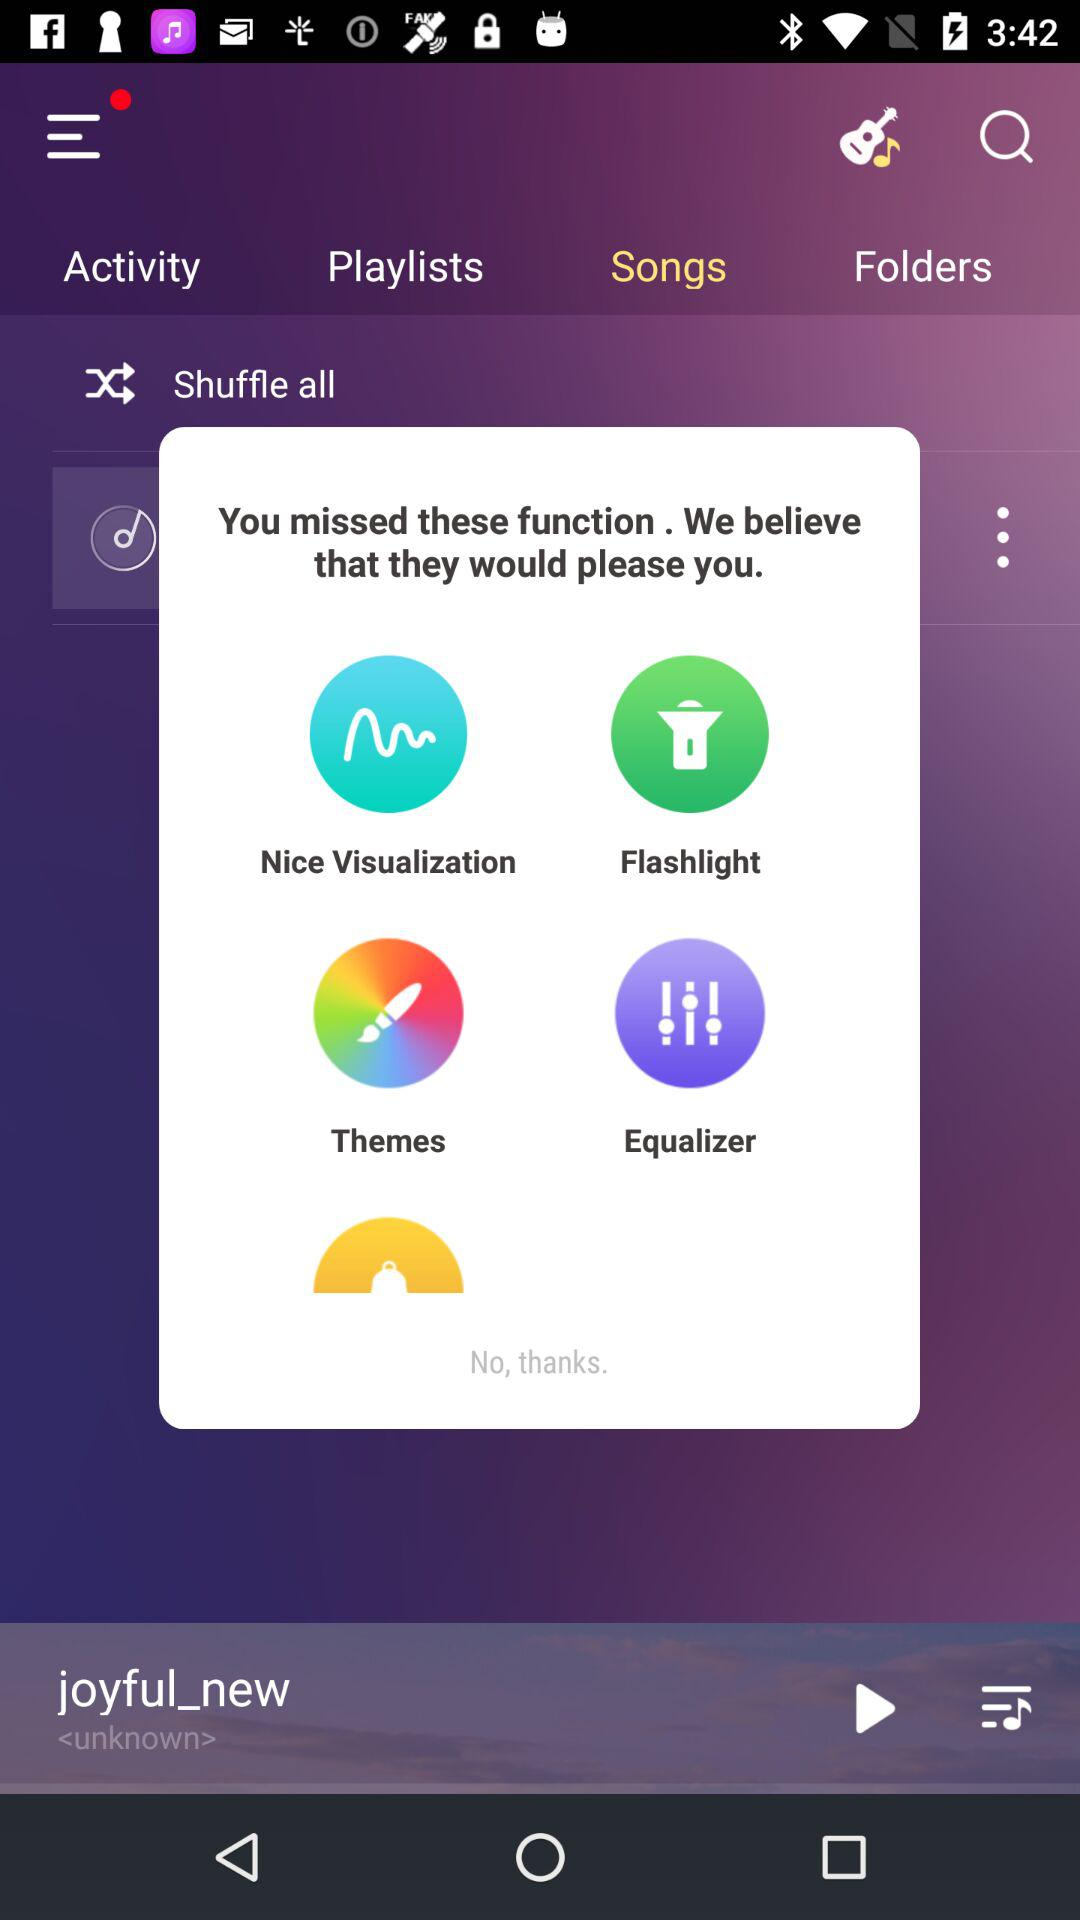Which tab is currently selected? The currently selected tab is "Songs". 